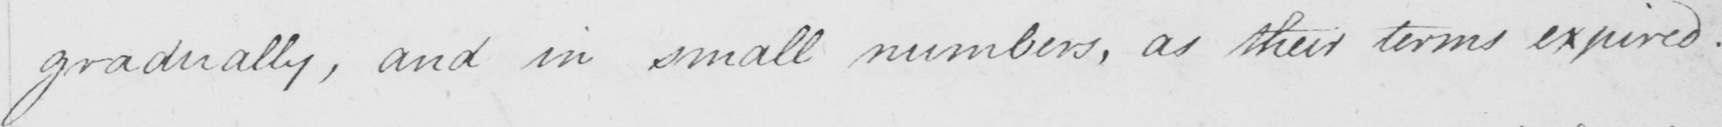Please provide the text content of this handwritten line. gradually , and in small numbers , as their terms expired . 